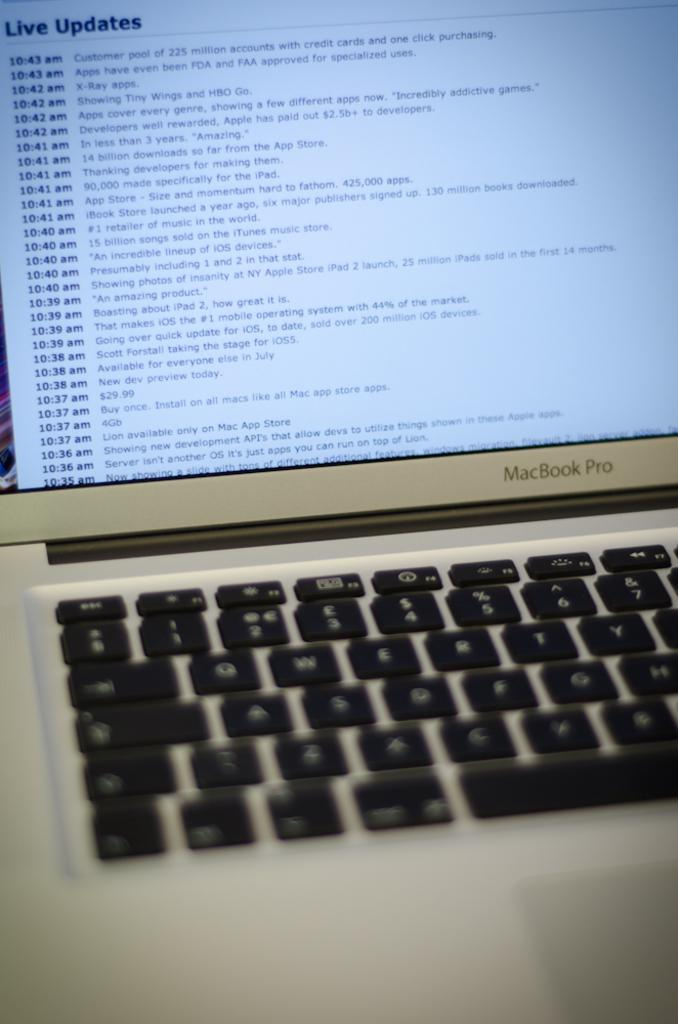<image>
Write a terse but informative summary of the picture. A laptop monitor showing Live Updates on the screen. 